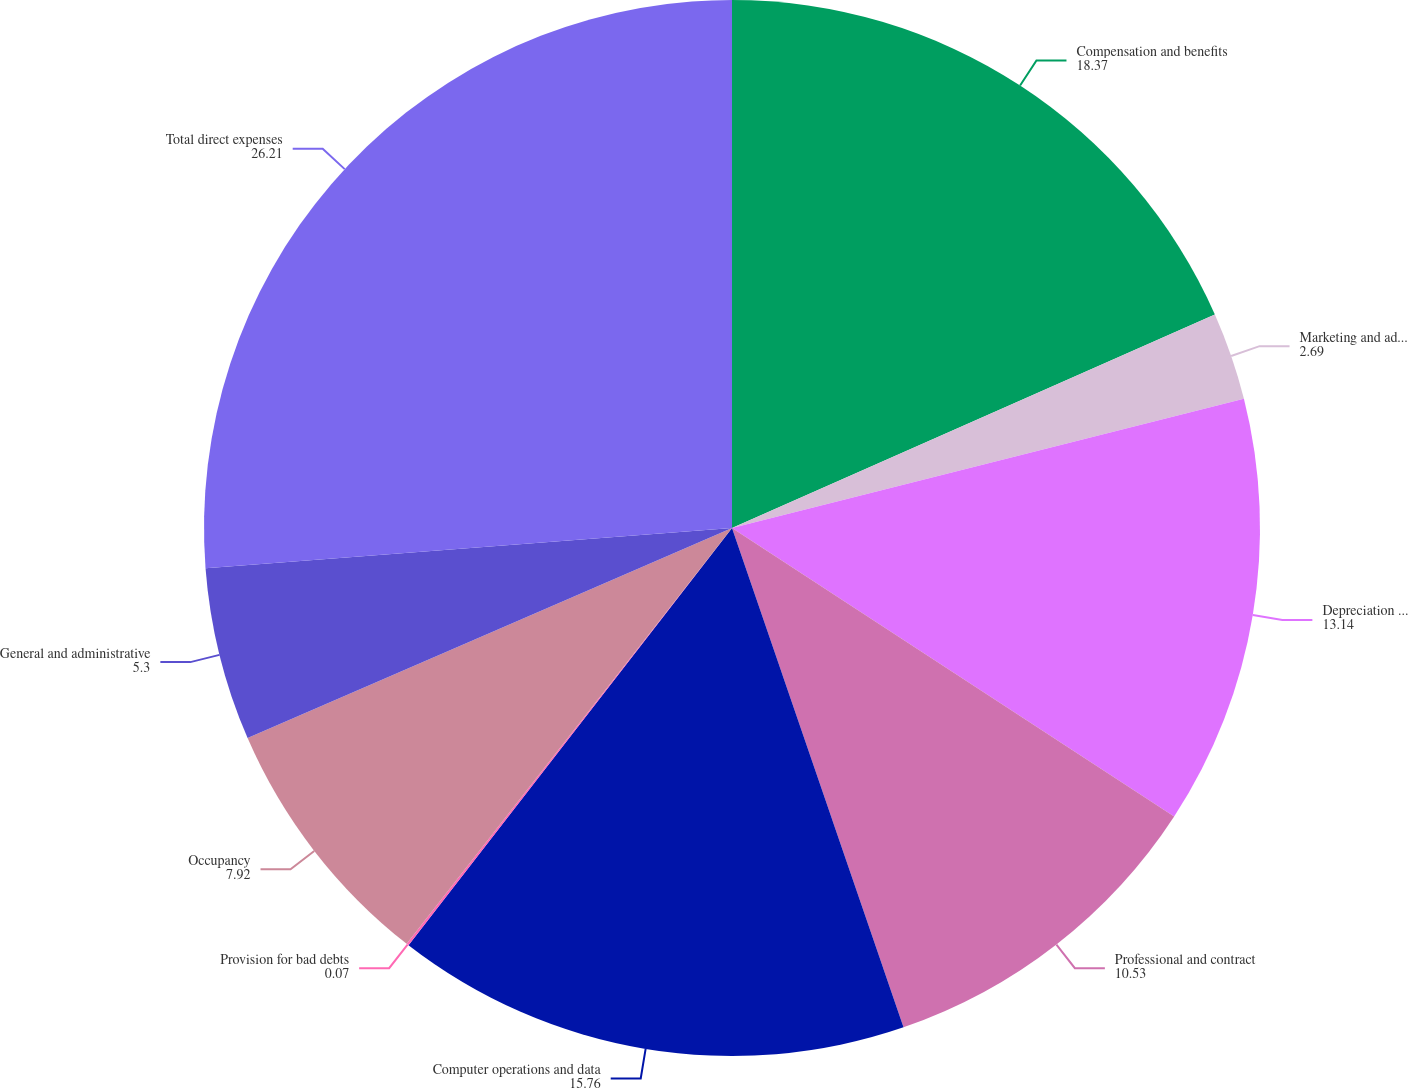<chart> <loc_0><loc_0><loc_500><loc_500><pie_chart><fcel>Compensation and benefits<fcel>Marketing and advertising<fcel>Depreciation and amortization<fcel>Professional and contract<fcel>Computer operations and data<fcel>Provision for bad debts<fcel>Occupancy<fcel>General and administrative<fcel>Total direct expenses<nl><fcel>18.37%<fcel>2.69%<fcel>13.14%<fcel>10.53%<fcel>15.76%<fcel>0.07%<fcel>7.92%<fcel>5.3%<fcel>26.21%<nl></chart> 